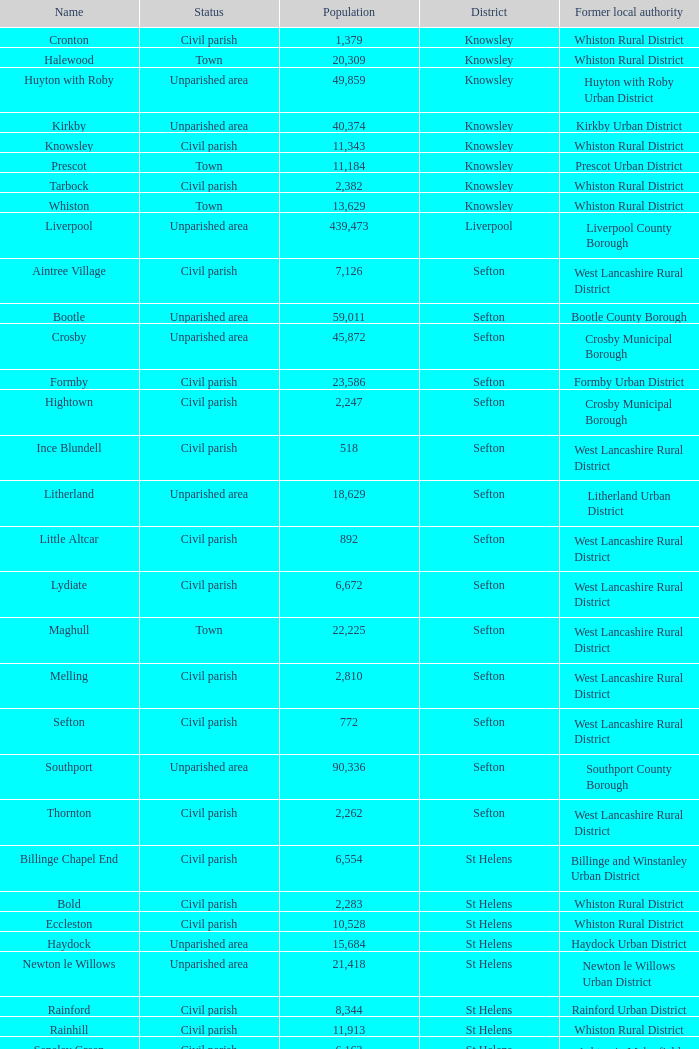What is the district of wallasey Wirral. 